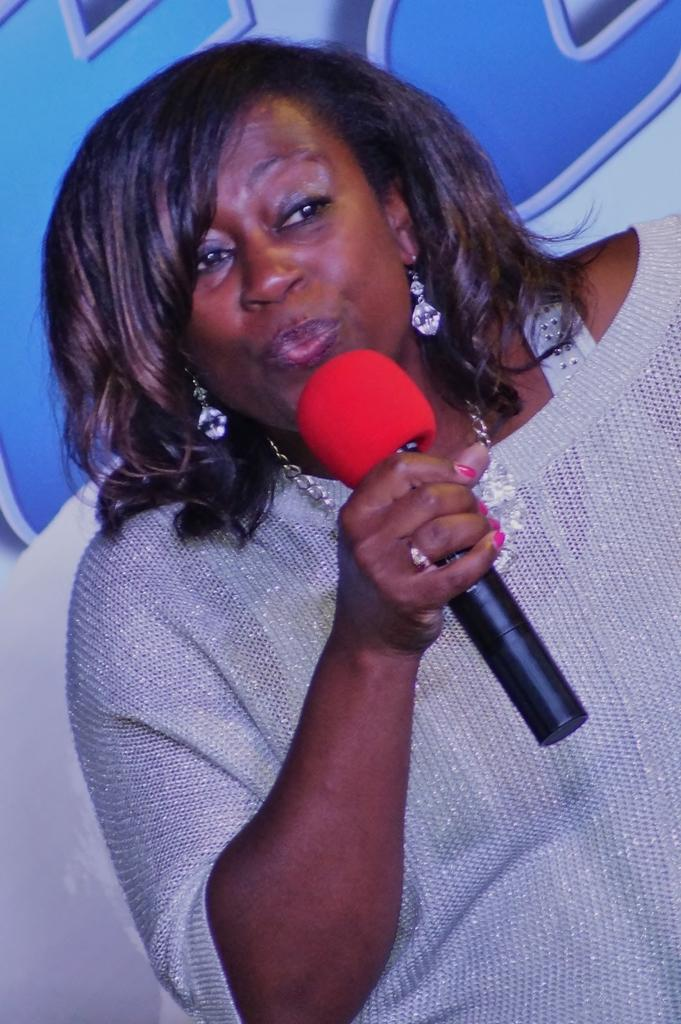Who is the main subject in the image? There is a woman in the image. What is the woman doing in the image? The woman is talking into a microphone. What can be seen in the background of the image? There is a hoarding in the background of the image. How many daughters does the goat have in the image? There is no goat or mention of daughters in the image; it features a woman talking into a microphone with a hoarding in the background. 